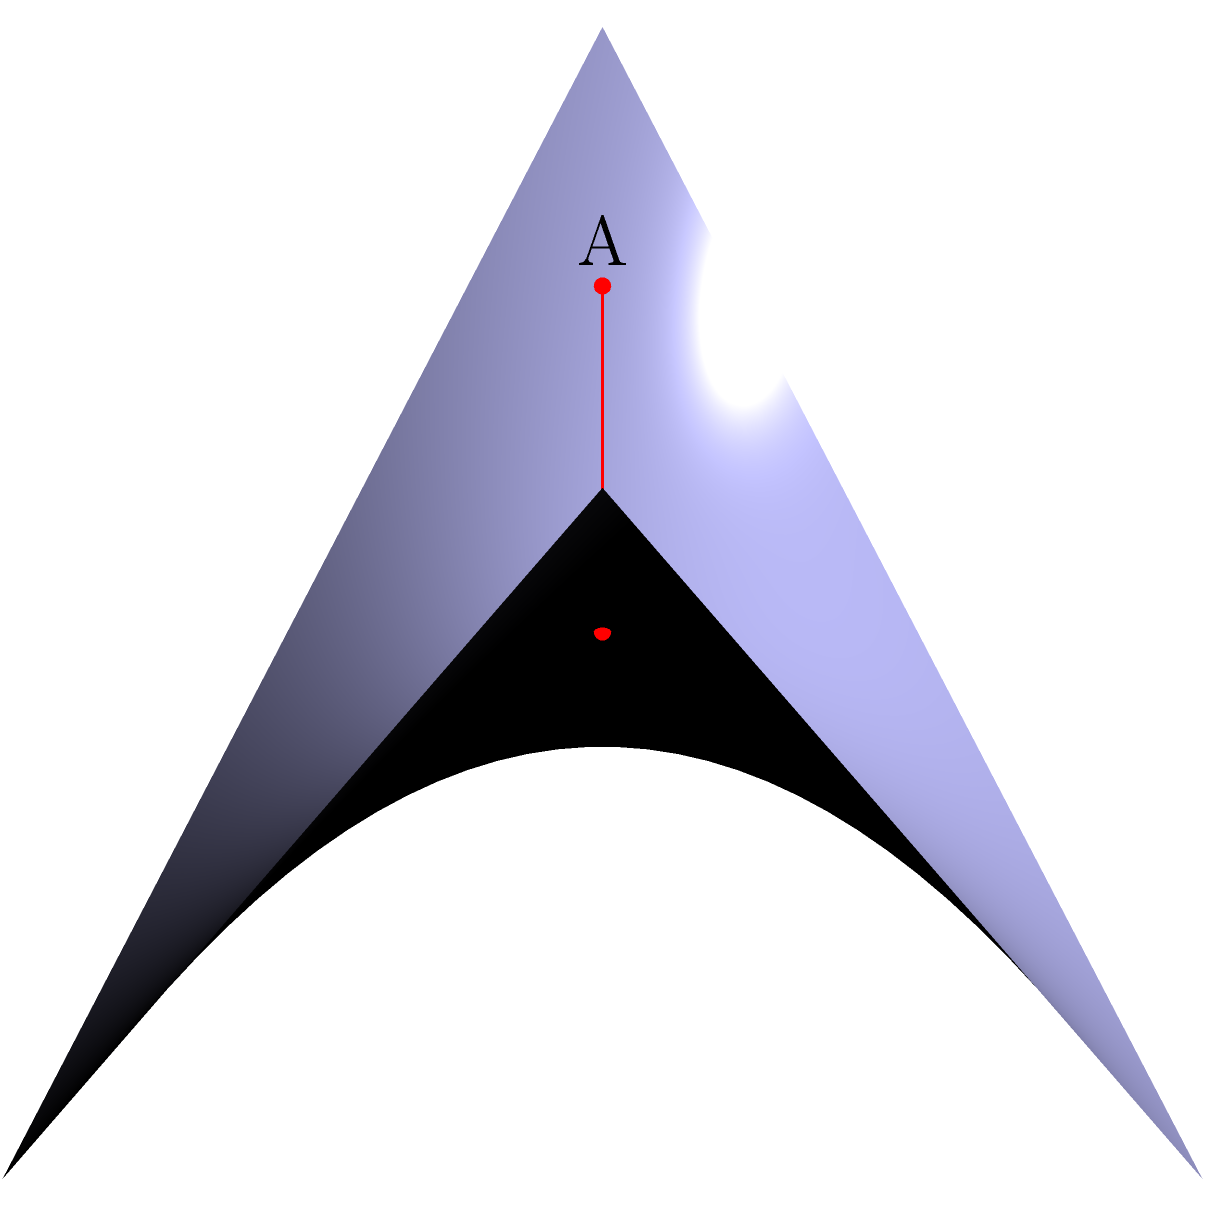In the context of Non-Euclidean Geometry, consider a hyperbolic paraboloid (saddle-shaped surface) represented by the equation $z = xy$. Two points, A and B, are located on this surface at coordinates $(-1.5, -1.5, 2.25)$ and $(1.5, 1.5, 2.25)$ respectively. What is the shape of the shortest path (geodesic) between these two points on this surface, and how does it differ from the shortest path in Euclidean space? To understand the shortest path between two points on a hyperbolic paraboloid, let's break it down step-by-step:

1) In Euclidean space, the shortest path between two points is always a straight line. However, on curved surfaces like our hyperbolic paraboloid, this is not the case.

2) The hyperbolic paraboloid is defined by the equation $z = xy$. This creates a saddle-shaped surface that curves both upward and downward.

3) On this surface, the geodesic (shortest path) between two points is not a straight line, but rather a curved path that follows the contours of the surface.

4) For the given points A $(-1.5, -1.5, 2.25)$ and B $(1.5, 1.5, 2.25)$, we can observe that they are symmetrically positioned on opposite sides of the saddle point (0, 0, 0).

5) Due to the symmetry of the surface and the positions of A and B, the geodesic between them will pass through the saddle point.

6) The path will curve downward as it approaches the center of the saddle, then curve upward as it moves away from the center towards the other point.

7) This curved path is shorter on the surface than a "straight" path would be if we tried to maintain a constant z-coordinate.

8) The shape of this geodesic can be approximated by a parabola when viewed from the side, although its exact shape is more complex and depends on the specific geometry of the surface.

9) In contrast, the shortest path in Euclidean space would be a straight line segment connecting A and B, which would not lie on the surface of the paraboloid except at its endpoints.

This difference highlights a fundamental principle of Non-Euclidean Geometry: the shortest path between two points depends on the geometry of the space in which they exist.
Answer: Curved path through saddle point, not straight line 